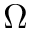Convert formula to latex. <formula><loc_0><loc_0><loc_500><loc_500>\Omega</formula> 